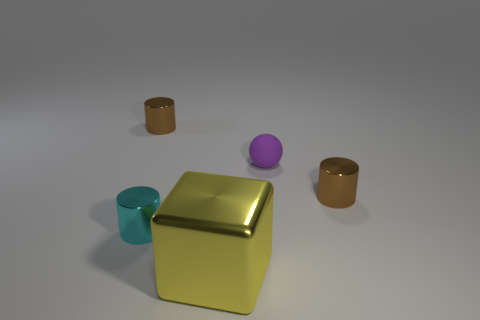Subtract 1 cylinders. How many cylinders are left? 2 Subtract all small brown cylinders. How many cylinders are left? 1 Subtract all blue balls. How many brown cylinders are left? 2 Add 5 tiny blue blocks. How many objects exist? 10 Subtract 0 green blocks. How many objects are left? 5 Subtract all blocks. How many objects are left? 4 Subtract all small red things. Subtract all brown objects. How many objects are left? 3 Add 3 cylinders. How many cylinders are left? 6 Add 3 tiny rubber cubes. How many tiny rubber cubes exist? 3 